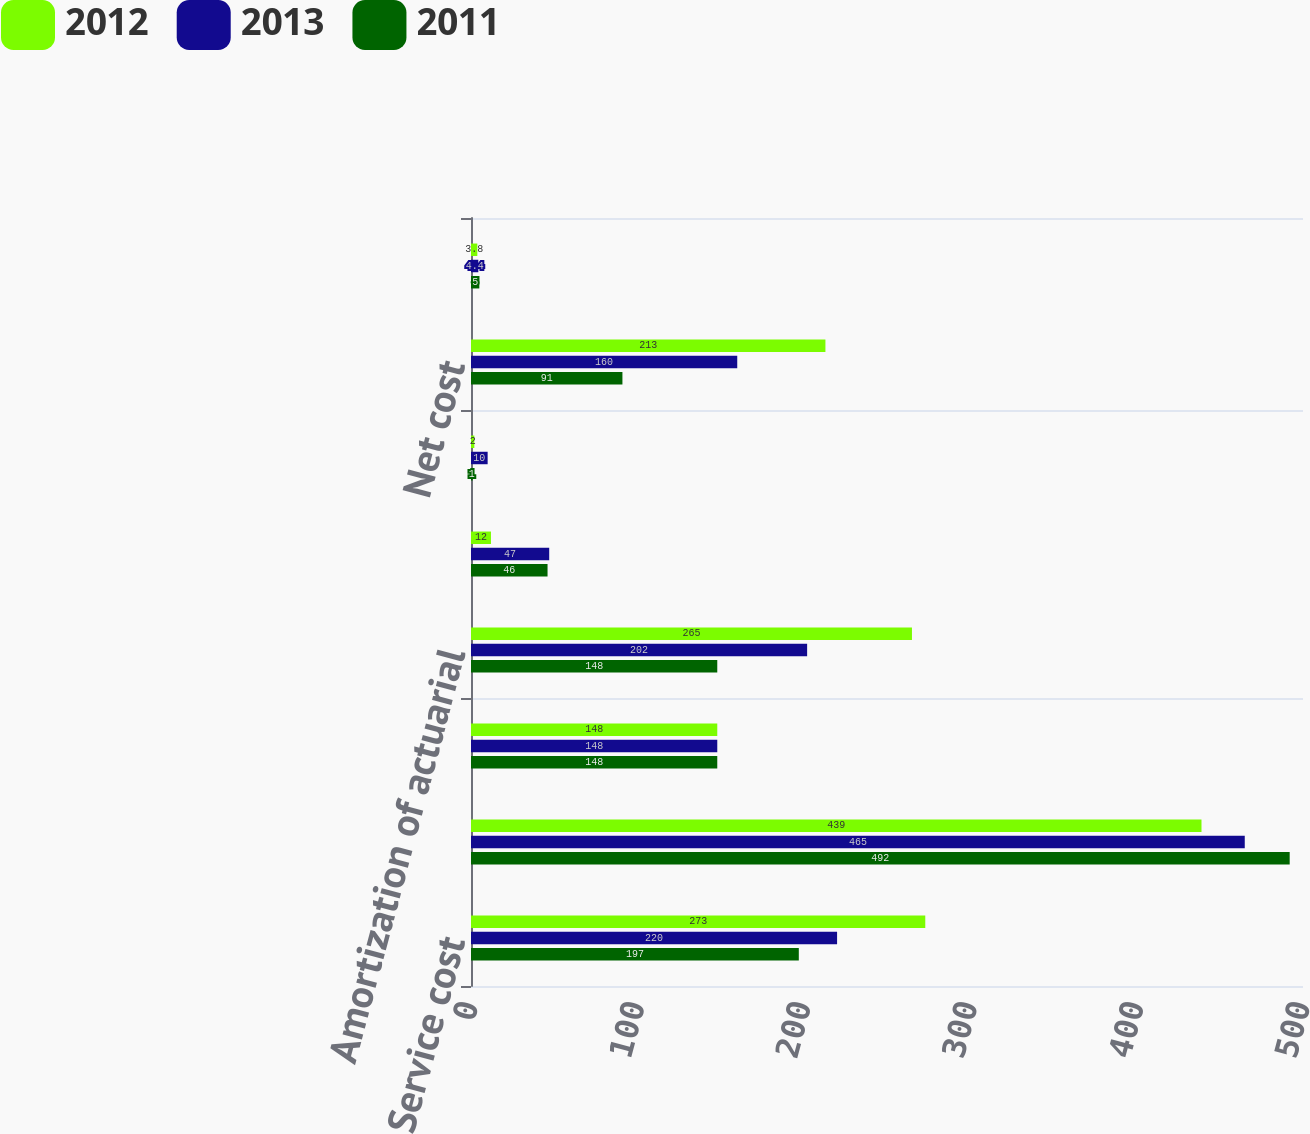<chart> <loc_0><loc_0><loc_500><loc_500><stacked_bar_chart><ecel><fcel>Service cost<fcel>Interest cost<fcel>Expected return on plan assets<fcel>Amortization of actuarial<fcel>Amortization of prior service<fcel>Settlements/curtailments<fcel>Net cost<fcel>Discount rates<nl><fcel>2012<fcel>273<fcel>439<fcel>148<fcel>265<fcel>12<fcel>2<fcel>213<fcel>3.8<nl><fcel>2013<fcel>220<fcel>465<fcel>148<fcel>202<fcel>47<fcel>10<fcel>160<fcel>4.4<nl><fcel>2011<fcel>197<fcel>492<fcel>148<fcel>148<fcel>46<fcel>1<fcel>91<fcel>5<nl></chart> 